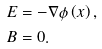Convert formula to latex. <formula><loc_0><loc_0><loc_500><loc_500>E & = - \nabla \phi \left ( x \right ) , \\ B & = 0 .</formula> 